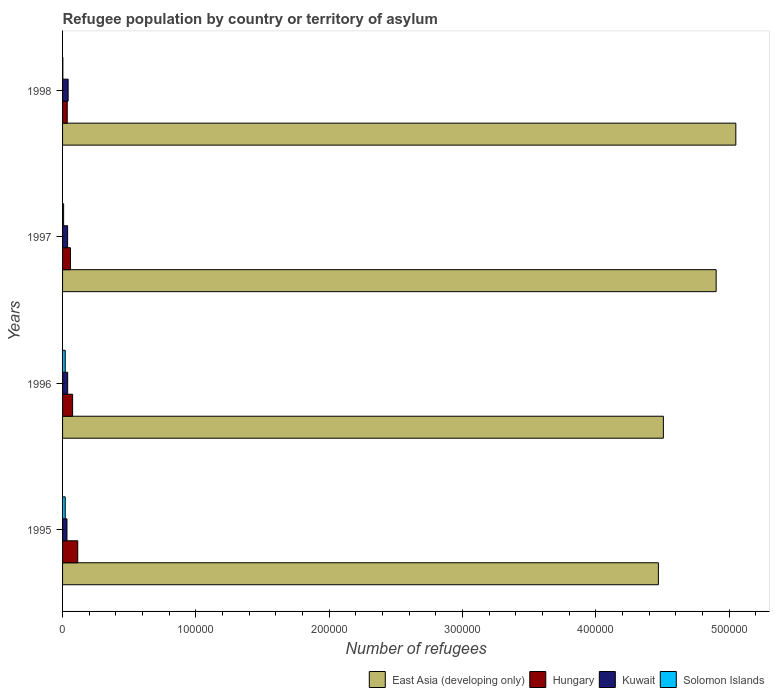How many different coloured bars are there?
Keep it short and to the point. 4. How many groups of bars are there?
Your answer should be very brief. 4. Are the number of bars per tick equal to the number of legend labels?
Offer a terse response. Yes. How many bars are there on the 3rd tick from the bottom?
Provide a short and direct response. 4. What is the number of refugees in Hungary in 1995?
Offer a terse response. 1.14e+04. Across all years, what is the maximum number of refugees in Hungary?
Give a very brief answer. 1.14e+04. Across all years, what is the minimum number of refugees in Hungary?
Offer a terse response. 3504. What is the total number of refugees in East Asia (developing only) in the graph?
Provide a short and direct response. 1.89e+06. What is the difference between the number of refugees in Hungary in 1995 and that in 1996?
Make the answer very short. 3857. What is the difference between the number of refugees in Solomon Islands in 1996 and the number of refugees in East Asia (developing only) in 1995?
Your response must be concise. -4.45e+05. What is the average number of refugees in Kuwait per year?
Provide a short and direct response. 3776.5. In the year 1998, what is the difference between the number of refugees in Solomon Islands and number of refugees in East Asia (developing only)?
Provide a short and direct response. -5.05e+05. In how many years, is the number of refugees in Hungary greater than 380000 ?
Your response must be concise. 0. What is the ratio of the number of refugees in East Asia (developing only) in 1995 to that in 1997?
Provide a succinct answer. 0.91. Is the difference between the number of refugees in Solomon Islands in 1995 and 1998 greater than the difference between the number of refugees in East Asia (developing only) in 1995 and 1998?
Provide a succinct answer. Yes. What is the difference between the highest and the second highest number of refugees in East Asia (developing only)?
Ensure brevity in your answer.  1.48e+04. What is the difference between the highest and the lowest number of refugees in Solomon Islands?
Your answer should be compact. 1790. In how many years, is the number of refugees in Solomon Islands greater than the average number of refugees in Solomon Islands taken over all years?
Offer a very short reply. 2. Is it the case that in every year, the sum of the number of refugees in East Asia (developing only) and number of refugees in Solomon Islands is greater than the sum of number of refugees in Kuwait and number of refugees in Hungary?
Your answer should be very brief. No. What does the 1st bar from the top in 1995 represents?
Your answer should be very brief. Solomon Islands. What does the 4th bar from the bottom in 1997 represents?
Your answer should be compact. Solomon Islands. Is it the case that in every year, the sum of the number of refugees in East Asia (developing only) and number of refugees in Kuwait is greater than the number of refugees in Solomon Islands?
Offer a very short reply. Yes. How many bars are there?
Offer a terse response. 16. Are all the bars in the graph horizontal?
Your answer should be compact. Yes. Are the values on the major ticks of X-axis written in scientific E-notation?
Your answer should be very brief. No. Does the graph contain any zero values?
Provide a succinct answer. No. Does the graph contain grids?
Your response must be concise. No. Where does the legend appear in the graph?
Your answer should be compact. Bottom right. What is the title of the graph?
Provide a short and direct response. Refugee population by country or territory of asylum. Does "Afghanistan" appear as one of the legend labels in the graph?
Offer a very short reply. No. What is the label or title of the X-axis?
Your answer should be very brief. Number of refugees. What is the Number of refugees in East Asia (developing only) in 1995?
Provide a short and direct response. 4.47e+05. What is the Number of refugees in Hungary in 1995?
Make the answer very short. 1.14e+04. What is the Number of refugees of Kuwait in 1995?
Keep it short and to the point. 3306. What is the Number of refugees in Solomon Islands in 1995?
Your answer should be very brief. 2000. What is the Number of refugees in East Asia (developing only) in 1996?
Offer a very short reply. 4.51e+05. What is the Number of refugees of Hungary in 1996?
Offer a terse response. 7537. What is the Number of refugees in Kuwait in 1996?
Make the answer very short. 3831. What is the Number of refugees of East Asia (developing only) in 1997?
Keep it short and to the point. 4.90e+05. What is the Number of refugees of Hungary in 1997?
Keep it short and to the point. 5890. What is the Number of refugees of Kuwait in 1997?
Your response must be concise. 3787. What is the Number of refugees of Solomon Islands in 1997?
Your response must be concise. 800. What is the Number of refugees of East Asia (developing only) in 1998?
Ensure brevity in your answer.  5.05e+05. What is the Number of refugees in Hungary in 1998?
Your answer should be very brief. 3504. What is the Number of refugees of Kuwait in 1998?
Offer a terse response. 4182. What is the Number of refugees of Solomon Islands in 1998?
Keep it short and to the point. 210. Across all years, what is the maximum Number of refugees in East Asia (developing only)?
Offer a terse response. 5.05e+05. Across all years, what is the maximum Number of refugees in Hungary?
Provide a short and direct response. 1.14e+04. Across all years, what is the maximum Number of refugees in Kuwait?
Keep it short and to the point. 4182. Across all years, what is the maximum Number of refugees of Solomon Islands?
Make the answer very short. 2000. Across all years, what is the minimum Number of refugees in East Asia (developing only)?
Your answer should be very brief. 4.47e+05. Across all years, what is the minimum Number of refugees of Hungary?
Keep it short and to the point. 3504. Across all years, what is the minimum Number of refugees in Kuwait?
Offer a very short reply. 3306. Across all years, what is the minimum Number of refugees of Solomon Islands?
Offer a very short reply. 210. What is the total Number of refugees of East Asia (developing only) in the graph?
Give a very brief answer. 1.89e+06. What is the total Number of refugees of Hungary in the graph?
Give a very brief answer. 2.83e+04. What is the total Number of refugees of Kuwait in the graph?
Provide a short and direct response. 1.51e+04. What is the total Number of refugees in Solomon Islands in the graph?
Ensure brevity in your answer.  5010. What is the difference between the Number of refugees of East Asia (developing only) in 1995 and that in 1996?
Your response must be concise. -3745. What is the difference between the Number of refugees of Hungary in 1995 and that in 1996?
Give a very brief answer. 3857. What is the difference between the Number of refugees in Kuwait in 1995 and that in 1996?
Provide a short and direct response. -525. What is the difference between the Number of refugees of Solomon Islands in 1995 and that in 1996?
Provide a short and direct response. 0. What is the difference between the Number of refugees in East Asia (developing only) in 1995 and that in 1997?
Offer a very short reply. -4.33e+04. What is the difference between the Number of refugees in Hungary in 1995 and that in 1997?
Provide a short and direct response. 5504. What is the difference between the Number of refugees in Kuwait in 1995 and that in 1997?
Ensure brevity in your answer.  -481. What is the difference between the Number of refugees in Solomon Islands in 1995 and that in 1997?
Your answer should be compact. 1200. What is the difference between the Number of refugees of East Asia (developing only) in 1995 and that in 1998?
Your answer should be compact. -5.81e+04. What is the difference between the Number of refugees of Hungary in 1995 and that in 1998?
Ensure brevity in your answer.  7890. What is the difference between the Number of refugees in Kuwait in 1995 and that in 1998?
Give a very brief answer. -876. What is the difference between the Number of refugees of Solomon Islands in 1995 and that in 1998?
Provide a succinct answer. 1790. What is the difference between the Number of refugees in East Asia (developing only) in 1996 and that in 1997?
Give a very brief answer. -3.96e+04. What is the difference between the Number of refugees in Hungary in 1996 and that in 1997?
Your answer should be compact. 1647. What is the difference between the Number of refugees in Kuwait in 1996 and that in 1997?
Offer a very short reply. 44. What is the difference between the Number of refugees in Solomon Islands in 1996 and that in 1997?
Your response must be concise. 1200. What is the difference between the Number of refugees of East Asia (developing only) in 1996 and that in 1998?
Offer a very short reply. -5.44e+04. What is the difference between the Number of refugees in Hungary in 1996 and that in 1998?
Offer a terse response. 4033. What is the difference between the Number of refugees of Kuwait in 1996 and that in 1998?
Your response must be concise. -351. What is the difference between the Number of refugees of Solomon Islands in 1996 and that in 1998?
Give a very brief answer. 1790. What is the difference between the Number of refugees in East Asia (developing only) in 1997 and that in 1998?
Provide a short and direct response. -1.48e+04. What is the difference between the Number of refugees in Hungary in 1997 and that in 1998?
Ensure brevity in your answer.  2386. What is the difference between the Number of refugees in Kuwait in 1997 and that in 1998?
Ensure brevity in your answer.  -395. What is the difference between the Number of refugees of Solomon Islands in 1997 and that in 1998?
Your answer should be very brief. 590. What is the difference between the Number of refugees in East Asia (developing only) in 1995 and the Number of refugees in Hungary in 1996?
Offer a terse response. 4.39e+05. What is the difference between the Number of refugees in East Asia (developing only) in 1995 and the Number of refugees in Kuwait in 1996?
Offer a terse response. 4.43e+05. What is the difference between the Number of refugees of East Asia (developing only) in 1995 and the Number of refugees of Solomon Islands in 1996?
Your answer should be very brief. 4.45e+05. What is the difference between the Number of refugees in Hungary in 1995 and the Number of refugees in Kuwait in 1996?
Your answer should be compact. 7563. What is the difference between the Number of refugees of Hungary in 1995 and the Number of refugees of Solomon Islands in 1996?
Give a very brief answer. 9394. What is the difference between the Number of refugees of Kuwait in 1995 and the Number of refugees of Solomon Islands in 1996?
Ensure brevity in your answer.  1306. What is the difference between the Number of refugees in East Asia (developing only) in 1995 and the Number of refugees in Hungary in 1997?
Your answer should be very brief. 4.41e+05. What is the difference between the Number of refugees of East Asia (developing only) in 1995 and the Number of refugees of Kuwait in 1997?
Give a very brief answer. 4.43e+05. What is the difference between the Number of refugees in East Asia (developing only) in 1995 and the Number of refugees in Solomon Islands in 1997?
Provide a succinct answer. 4.46e+05. What is the difference between the Number of refugees of Hungary in 1995 and the Number of refugees of Kuwait in 1997?
Offer a terse response. 7607. What is the difference between the Number of refugees of Hungary in 1995 and the Number of refugees of Solomon Islands in 1997?
Ensure brevity in your answer.  1.06e+04. What is the difference between the Number of refugees of Kuwait in 1995 and the Number of refugees of Solomon Islands in 1997?
Provide a short and direct response. 2506. What is the difference between the Number of refugees of East Asia (developing only) in 1995 and the Number of refugees of Hungary in 1998?
Provide a short and direct response. 4.43e+05. What is the difference between the Number of refugees of East Asia (developing only) in 1995 and the Number of refugees of Kuwait in 1998?
Your answer should be compact. 4.43e+05. What is the difference between the Number of refugees in East Asia (developing only) in 1995 and the Number of refugees in Solomon Islands in 1998?
Your answer should be very brief. 4.47e+05. What is the difference between the Number of refugees of Hungary in 1995 and the Number of refugees of Kuwait in 1998?
Provide a short and direct response. 7212. What is the difference between the Number of refugees in Hungary in 1995 and the Number of refugees in Solomon Islands in 1998?
Keep it short and to the point. 1.12e+04. What is the difference between the Number of refugees in Kuwait in 1995 and the Number of refugees in Solomon Islands in 1998?
Provide a short and direct response. 3096. What is the difference between the Number of refugees of East Asia (developing only) in 1996 and the Number of refugees of Hungary in 1997?
Your response must be concise. 4.45e+05. What is the difference between the Number of refugees of East Asia (developing only) in 1996 and the Number of refugees of Kuwait in 1997?
Your answer should be compact. 4.47e+05. What is the difference between the Number of refugees in East Asia (developing only) in 1996 and the Number of refugees in Solomon Islands in 1997?
Your response must be concise. 4.50e+05. What is the difference between the Number of refugees of Hungary in 1996 and the Number of refugees of Kuwait in 1997?
Ensure brevity in your answer.  3750. What is the difference between the Number of refugees of Hungary in 1996 and the Number of refugees of Solomon Islands in 1997?
Offer a very short reply. 6737. What is the difference between the Number of refugees of Kuwait in 1996 and the Number of refugees of Solomon Islands in 1997?
Your answer should be very brief. 3031. What is the difference between the Number of refugees of East Asia (developing only) in 1996 and the Number of refugees of Hungary in 1998?
Give a very brief answer. 4.47e+05. What is the difference between the Number of refugees of East Asia (developing only) in 1996 and the Number of refugees of Kuwait in 1998?
Offer a terse response. 4.47e+05. What is the difference between the Number of refugees of East Asia (developing only) in 1996 and the Number of refugees of Solomon Islands in 1998?
Offer a very short reply. 4.51e+05. What is the difference between the Number of refugees of Hungary in 1996 and the Number of refugees of Kuwait in 1998?
Offer a terse response. 3355. What is the difference between the Number of refugees of Hungary in 1996 and the Number of refugees of Solomon Islands in 1998?
Your answer should be compact. 7327. What is the difference between the Number of refugees in Kuwait in 1996 and the Number of refugees in Solomon Islands in 1998?
Offer a very short reply. 3621. What is the difference between the Number of refugees of East Asia (developing only) in 1997 and the Number of refugees of Hungary in 1998?
Your answer should be compact. 4.87e+05. What is the difference between the Number of refugees in East Asia (developing only) in 1997 and the Number of refugees in Kuwait in 1998?
Your answer should be very brief. 4.86e+05. What is the difference between the Number of refugees of East Asia (developing only) in 1997 and the Number of refugees of Solomon Islands in 1998?
Offer a very short reply. 4.90e+05. What is the difference between the Number of refugees of Hungary in 1997 and the Number of refugees of Kuwait in 1998?
Provide a succinct answer. 1708. What is the difference between the Number of refugees of Hungary in 1997 and the Number of refugees of Solomon Islands in 1998?
Make the answer very short. 5680. What is the difference between the Number of refugees in Kuwait in 1997 and the Number of refugees in Solomon Islands in 1998?
Provide a short and direct response. 3577. What is the average Number of refugees in East Asia (developing only) per year?
Make the answer very short. 4.73e+05. What is the average Number of refugees in Hungary per year?
Ensure brevity in your answer.  7081.25. What is the average Number of refugees in Kuwait per year?
Offer a terse response. 3776.5. What is the average Number of refugees in Solomon Islands per year?
Ensure brevity in your answer.  1252.5. In the year 1995, what is the difference between the Number of refugees in East Asia (developing only) and Number of refugees in Hungary?
Keep it short and to the point. 4.36e+05. In the year 1995, what is the difference between the Number of refugees of East Asia (developing only) and Number of refugees of Kuwait?
Your answer should be compact. 4.44e+05. In the year 1995, what is the difference between the Number of refugees in East Asia (developing only) and Number of refugees in Solomon Islands?
Ensure brevity in your answer.  4.45e+05. In the year 1995, what is the difference between the Number of refugees of Hungary and Number of refugees of Kuwait?
Provide a succinct answer. 8088. In the year 1995, what is the difference between the Number of refugees of Hungary and Number of refugees of Solomon Islands?
Ensure brevity in your answer.  9394. In the year 1995, what is the difference between the Number of refugees of Kuwait and Number of refugees of Solomon Islands?
Give a very brief answer. 1306. In the year 1996, what is the difference between the Number of refugees of East Asia (developing only) and Number of refugees of Hungary?
Ensure brevity in your answer.  4.43e+05. In the year 1996, what is the difference between the Number of refugees of East Asia (developing only) and Number of refugees of Kuwait?
Your answer should be compact. 4.47e+05. In the year 1996, what is the difference between the Number of refugees in East Asia (developing only) and Number of refugees in Solomon Islands?
Offer a very short reply. 4.49e+05. In the year 1996, what is the difference between the Number of refugees of Hungary and Number of refugees of Kuwait?
Provide a short and direct response. 3706. In the year 1996, what is the difference between the Number of refugees of Hungary and Number of refugees of Solomon Islands?
Give a very brief answer. 5537. In the year 1996, what is the difference between the Number of refugees of Kuwait and Number of refugees of Solomon Islands?
Give a very brief answer. 1831. In the year 1997, what is the difference between the Number of refugees in East Asia (developing only) and Number of refugees in Hungary?
Your answer should be compact. 4.84e+05. In the year 1997, what is the difference between the Number of refugees in East Asia (developing only) and Number of refugees in Kuwait?
Offer a terse response. 4.87e+05. In the year 1997, what is the difference between the Number of refugees of East Asia (developing only) and Number of refugees of Solomon Islands?
Your answer should be compact. 4.90e+05. In the year 1997, what is the difference between the Number of refugees in Hungary and Number of refugees in Kuwait?
Ensure brevity in your answer.  2103. In the year 1997, what is the difference between the Number of refugees of Hungary and Number of refugees of Solomon Islands?
Ensure brevity in your answer.  5090. In the year 1997, what is the difference between the Number of refugees in Kuwait and Number of refugees in Solomon Islands?
Keep it short and to the point. 2987. In the year 1998, what is the difference between the Number of refugees of East Asia (developing only) and Number of refugees of Hungary?
Keep it short and to the point. 5.02e+05. In the year 1998, what is the difference between the Number of refugees of East Asia (developing only) and Number of refugees of Kuwait?
Your response must be concise. 5.01e+05. In the year 1998, what is the difference between the Number of refugees of East Asia (developing only) and Number of refugees of Solomon Islands?
Keep it short and to the point. 5.05e+05. In the year 1998, what is the difference between the Number of refugees of Hungary and Number of refugees of Kuwait?
Offer a terse response. -678. In the year 1998, what is the difference between the Number of refugees of Hungary and Number of refugees of Solomon Islands?
Your response must be concise. 3294. In the year 1998, what is the difference between the Number of refugees of Kuwait and Number of refugees of Solomon Islands?
Provide a succinct answer. 3972. What is the ratio of the Number of refugees of East Asia (developing only) in 1995 to that in 1996?
Your response must be concise. 0.99. What is the ratio of the Number of refugees in Hungary in 1995 to that in 1996?
Provide a succinct answer. 1.51. What is the ratio of the Number of refugees in Kuwait in 1995 to that in 1996?
Give a very brief answer. 0.86. What is the ratio of the Number of refugees in East Asia (developing only) in 1995 to that in 1997?
Offer a terse response. 0.91. What is the ratio of the Number of refugees of Hungary in 1995 to that in 1997?
Your answer should be compact. 1.93. What is the ratio of the Number of refugees of Kuwait in 1995 to that in 1997?
Your answer should be very brief. 0.87. What is the ratio of the Number of refugees in East Asia (developing only) in 1995 to that in 1998?
Offer a terse response. 0.89. What is the ratio of the Number of refugees of Hungary in 1995 to that in 1998?
Your answer should be compact. 3.25. What is the ratio of the Number of refugees in Kuwait in 1995 to that in 1998?
Offer a terse response. 0.79. What is the ratio of the Number of refugees of Solomon Islands in 1995 to that in 1998?
Provide a short and direct response. 9.52. What is the ratio of the Number of refugees of East Asia (developing only) in 1996 to that in 1997?
Give a very brief answer. 0.92. What is the ratio of the Number of refugees of Hungary in 1996 to that in 1997?
Provide a short and direct response. 1.28. What is the ratio of the Number of refugees in Kuwait in 1996 to that in 1997?
Your answer should be very brief. 1.01. What is the ratio of the Number of refugees in East Asia (developing only) in 1996 to that in 1998?
Your answer should be very brief. 0.89. What is the ratio of the Number of refugees in Hungary in 1996 to that in 1998?
Your answer should be very brief. 2.15. What is the ratio of the Number of refugees in Kuwait in 1996 to that in 1998?
Your answer should be very brief. 0.92. What is the ratio of the Number of refugees in Solomon Islands in 1996 to that in 1998?
Your answer should be compact. 9.52. What is the ratio of the Number of refugees in East Asia (developing only) in 1997 to that in 1998?
Keep it short and to the point. 0.97. What is the ratio of the Number of refugees of Hungary in 1997 to that in 1998?
Your answer should be compact. 1.68. What is the ratio of the Number of refugees of Kuwait in 1997 to that in 1998?
Keep it short and to the point. 0.91. What is the ratio of the Number of refugees of Solomon Islands in 1997 to that in 1998?
Provide a succinct answer. 3.81. What is the difference between the highest and the second highest Number of refugees of East Asia (developing only)?
Ensure brevity in your answer.  1.48e+04. What is the difference between the highest and the second highest Number of refugees in Hungary?
Your answer should be compact. 3857. What is the difference between the highest and the second highest Number of refugees in Kuwait?
Offer a very short reply. 351. What is the difference between the highest and the lowest Number of refugees in East Asia (developing only)?
Offer a terse response. 5.81e+04. What is the difference between the highest and the lowest Number of refugees of Hungary?
Your answer should be compact. 7890. What is the difference between the highest and the lowest Number of refugees of Kuwait?
Offer a very short reply. 876. What is the difference between the highest and the lowest Number of refugees of Solomon Islands?
Offer a very short reply. 1790. 